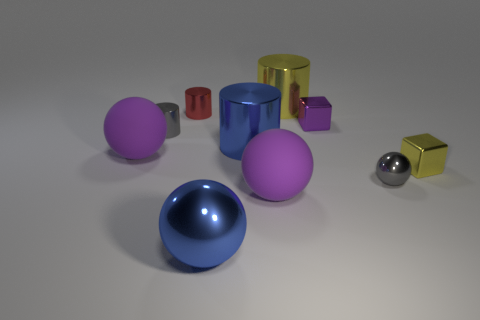Subtract all cylinders. How many objects are left? 6 Add 8 tiny spheres. How many tiny spheres are left? 9 Add 2 big metal balls. How many big metal balls exist? 3 Subtract 0 green balls. How many objects are left? 10 Subtract all big blue cylinders. Subtract all big shiny things. How many objects are left? 6 